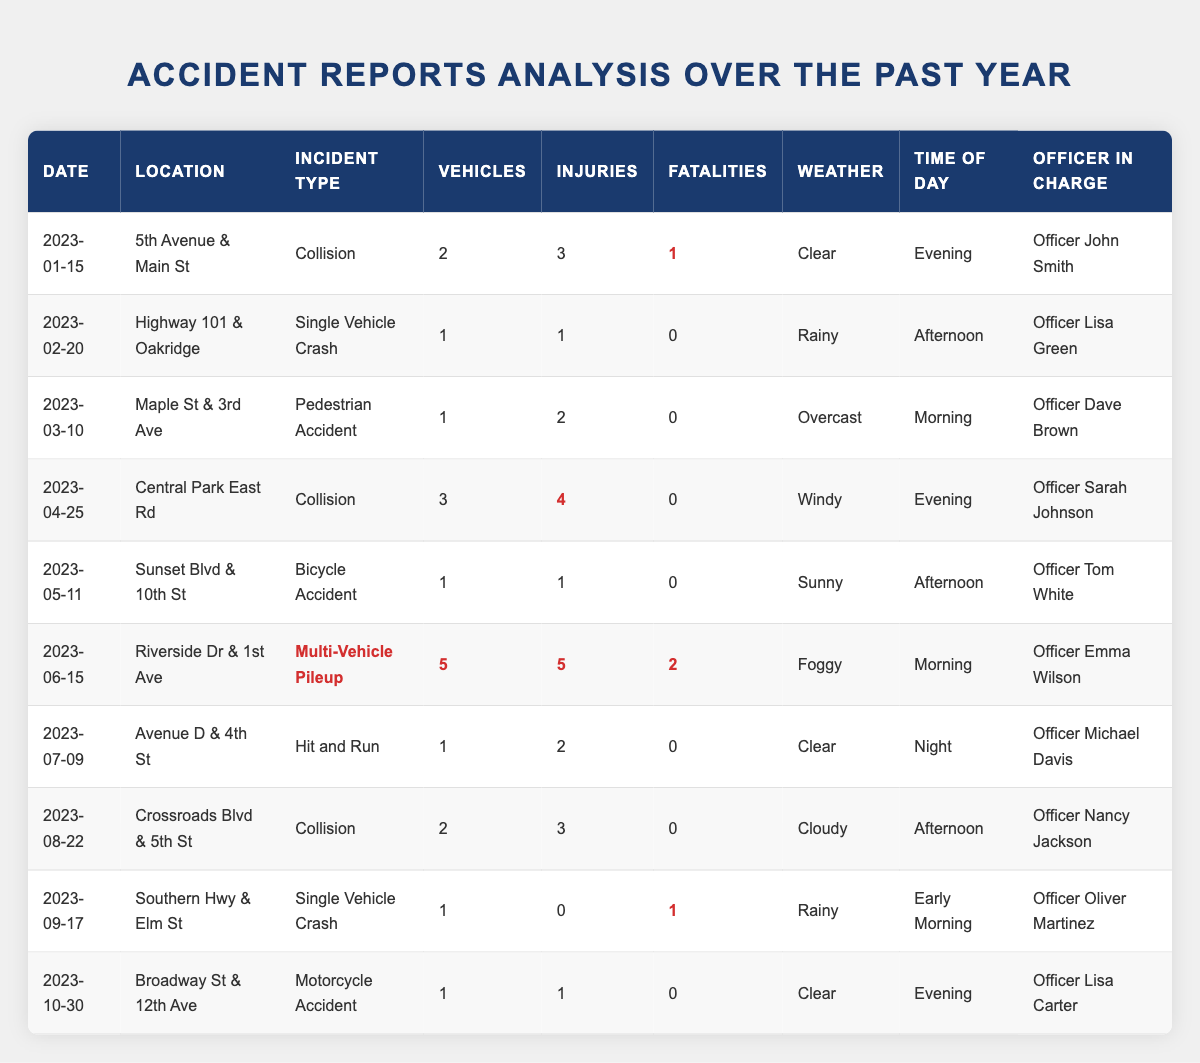What date had the highest number of injuries reported? The highest number of injuries reported is 5, which occurred on June 15, 2023, during a multi-vehicle pileup incident.
Answer: June 15, 2023 How many collisions were reported in total? There are 4 entries labeled as "Collision" in the incident type column from the table.
Answer: 4 Was there any accident with fatalities in clear weather conditions? Yes, the collision on January 15, 2023, resulted in 1 fatality and occurred in clear weather conditions.
Answer: Yes What is the total number of fatalities reported across all incidents? Adding the fatalities from each incident: 1 (Jan) + 0 (Feb) + 0 (Mar) + 0 (Apr) + 0 (May) + 2 (Jun) + 0 (Jul) + 0 (Aug) + 1 (Sep) + 0 (Oct) gives us a total of 4 fatalities.
Answer: 4 Which officer handled the incident with the most vehicles involved? The incident with the most vehicles involved was the multi-vehicle pileup on June 15, 2023, which had 5 vehicles, handled by Officer Emma Wilson.
Answer: Officer Emma Wilson During which time of day were the most incidents reported in total? Counting the incidents by time of day: Evening (3), Afternoon (4), Morning (3), Early Morning (1), Night (1) shows that most incidents occurred in the Afternoon with 4 reports.
Answer: Afternoon How many incidents occurred during rainy weather conditions? There were 3 incidents that occurred during rainy weather conditions: February, September, and one listed in January.
Answer: 3 What was the average number of injuries reported per incident? The total number of injuries reported is 15 (3 + 1 + 2 + 4 + 1 + 5 + 2 + 3 + 0 + 1) across 10 incidents, giving an average of 15/10 = 1.5 injuries per incident.
Answer: 1.5 Which incident had the most severe outcome in terms of fatalities? The multi-vehicle pileup on June 15, 2023, had the most severe outcome with 2 fatalities.
Answer: Multi-Vehicle Pileup on June 15, 2023 Was there an incident involving a bicycle? Yes, there was a bicycle accident reported on May 11, 2023.
Answer: Yes 